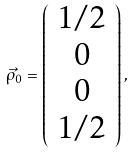<formula> <loc_0><loc_0><loc_500><loc_500>\vec { \rho } _ { 0 } = \left ( \begin{array} { c } 1 / 2 \\ 0 \\ 0 \\ 1 / 2 \end{array} \right ) ,</formula> 